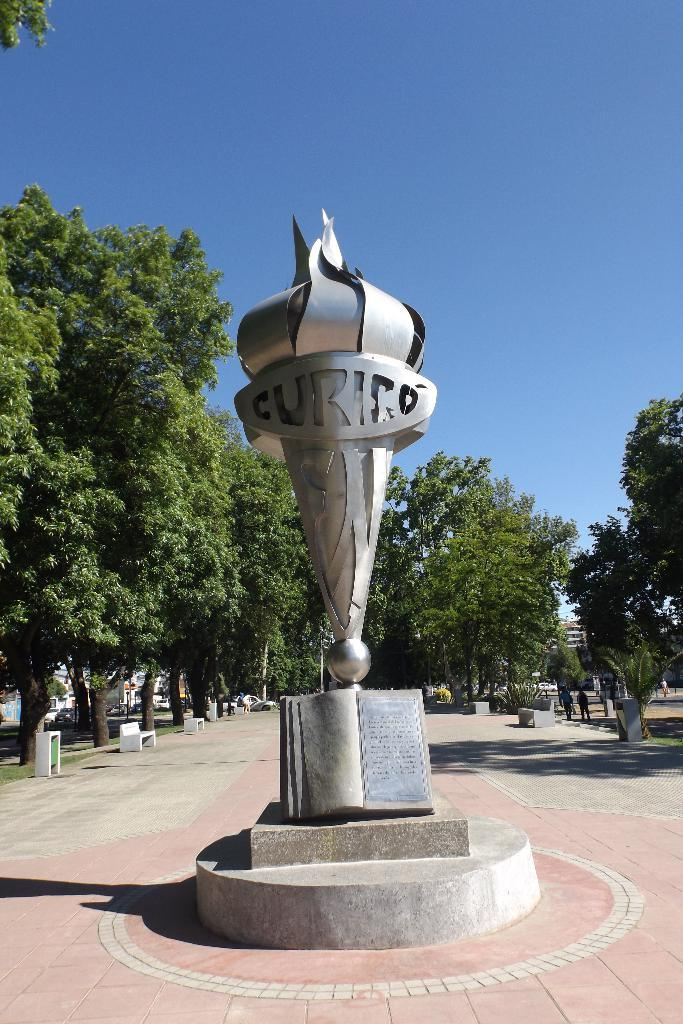Provide a one-sentence caption for the provided image. A statue that has the letter CURICO on it. 